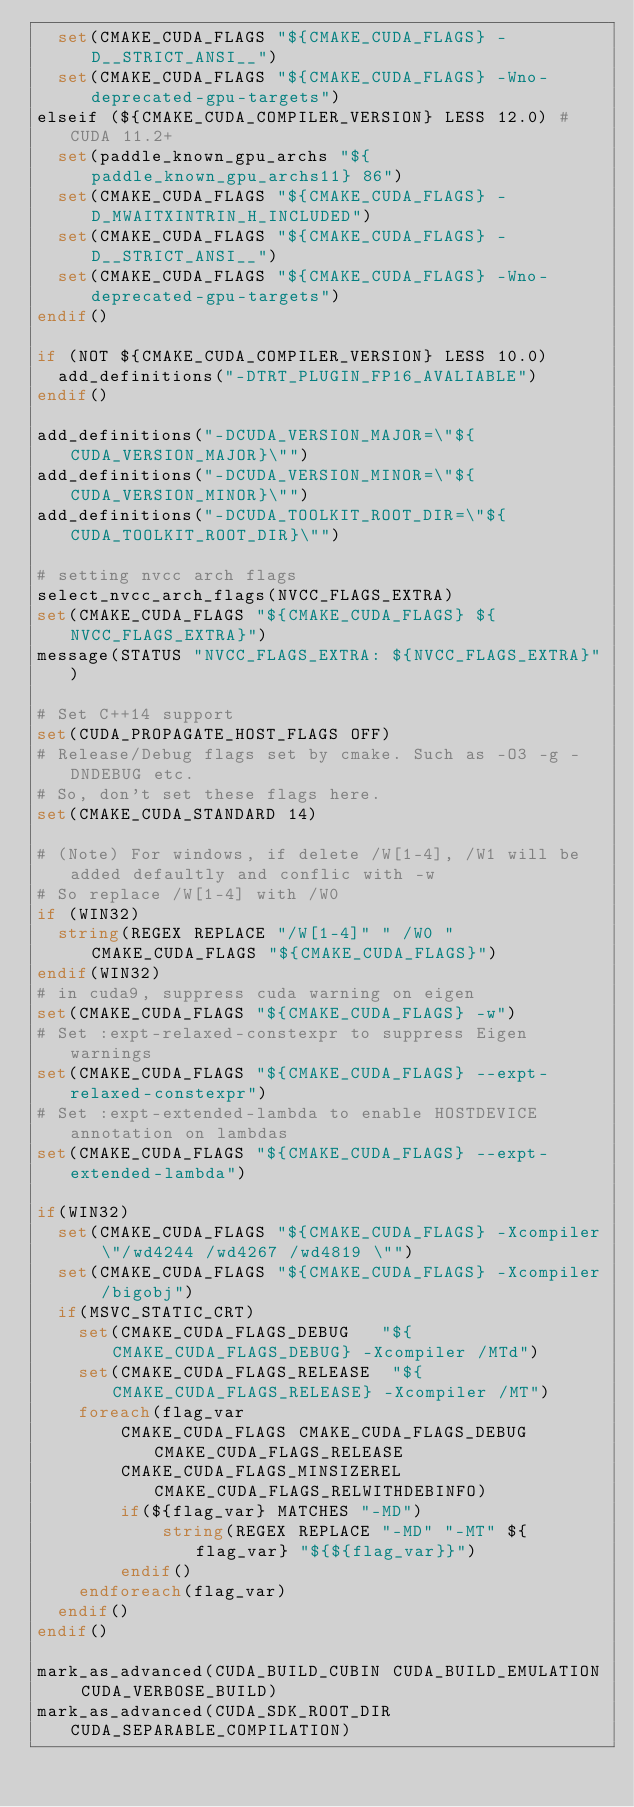<code> <loc_0><loc_0><loc_500><loc_500><_CMake_>  set(CMAKE_CUDA_FLAGS "${CMAKE_CUDA_FLAGS} -D__STRICT_ANSI__")
  set(CMAKE_CUDA_FLAGS "${CMAKE_CUDA_FLAGS} -Wno-deprecated-gpu-targets")
elseif (${CMAKE_CUDA_COMPILER_VERSION} LESS 12.0) # CUDA 11.2+
  set(paddle_known_gpu_archs "${paddle_known_gpu_archs11} 86")
  set(CMAKE_CUDA_FLAGS "${CMAKE_CUDA_FLAGS} -D_MWAITXINTRIN_H_INCLUDED")
  set(CMAKE_CUDA_FLAGS "${CMAKE_CUDA_FLAGS} -D__STRICT_ANSI__")
  set(CMAKE_CUDA_FLAGS "${CMAKE_CUDA_FLAGS} -Wno-deprecated-gpu-targets")
endif()

if (NOT ${CMAKE_CUDA_COMPILER_VERSION} LESS 10.0)
  add_definitions("-DTRT_PLUGIN_FP16_AVALIABLE")
endif()

add_definitions("-DCUDA_VERSION_MAJOR=\"${CUDA_VERSION_MAJOR}\"")
add_definitions("-DCUDA_VERSION_MINOR=\"${CUDA_VERSION_MINOR}\"")
add_definitions("-DCUDA_TOOLKIT_ROOT_DIR=\"${CUDA_TOOLKIT_ROOT_DIR}\"")

# setting nvcc arch flags
select_nvcc_arch_flags(NVCC_FLAGS_EXTRA)
set(CMAKE_CUDA_FLAGS "${CMAKE_CUDA_FLAGS} ${NVCC_FLAGS_EXTRA}")
message(STATUS "NVCC_FLAGS_EXTRA: ${NVCC_FLAGS_EXTRA}")

# Set C++14 support
set(CUDA_PROPAGATE_HOST_FLAGS OFF)
# Release/Debug flags set by cmake. Such as -O3 -g -DNDEBUG etc.
# So, don't set these flags here.
set(CMAKE_CUDA_STANDARD 14)

# (Note) For windows, if delete /W[1-4], /W1 will be added defaultly and conflic with -w
# So replace /W[1-4] with /W0
if (WIN32)
  string(REGEX REPLACE "/W[1-4]" " /W0 " CMAKE_CUDA_FLAGS "${CMAKE_CUDA_FLAGS}")
endif(WIN32)
# in cuda9, suppress cuda warning on eigen
set(CMAKE_CUDA_FLAGS "${CMAKE_CUDA_FLAGS} -w")
# Set :expt-relaxed-constexpr to suppress Eigen warnings
set(CMAKE_CUDA_FLAGS "${CMAKE_CUDA_FLAGS} --expt-relaxed-constexpr")
# Set :expt-extended-lambda to enable HOSTDEVICE annotation on lambdas
set(CMAKE_CUDA_FLAGS "${CMAKE_CUDA_FLAGS} --expt-extended-lambda")

if(WIN32)
  set(CMAKE_CUDA_FLAGS "${CMAKE_CUDA_FLAGS} -Xcompiler \"/wd4244 /wd4267 /wd4819 \"")
  set(CMAKE_CUDA_FLAGS "${CMAKE_CUDA_FLAGS} -Xcompiler /bigobj")
  if(MSVC_STATIC_CRT)
    set(CMAKE_CUDA_FLAGS_DEBUG   "${CMAKE_CUDA_FLAGS_DEBUG} -Xcompiler /MTd")
    set(CMAKE_CUDA_FLAGS_RELEASE  "${CMAKE_CUDA_FLAGS_RELEASE} -Xcompiler /MT")
    foreach(flag_var
        CMAKE_CUDA_FLAGS CMAKE_CUDA_FLAGS_DEBUG CMAKE_CUDA_FLAGS_RELEASE
        CMAKE_CUDA_FLAGS_MINSIZEREL CMAKE_CUDA_FLAGS_RELWITHDEBINFO)
        if(${flag_var} MATCHES "-MD")
            string(REGEX REPLACE "-MD" "-MT" ${flag_var} "${${flag_var}}")
        endif()
    endforeach(flag_var)
  endif()
endif()

mark_as_advanced(CUDA_BUILD_CUBIN CUDA_BUILD_EMULATION CUDA_VERBOSE_BUILD)
mark_as_advanced(CUDA_SDK_ROOT_DIR CUDA_SEPARABLE_COMPILATION)

</code> 